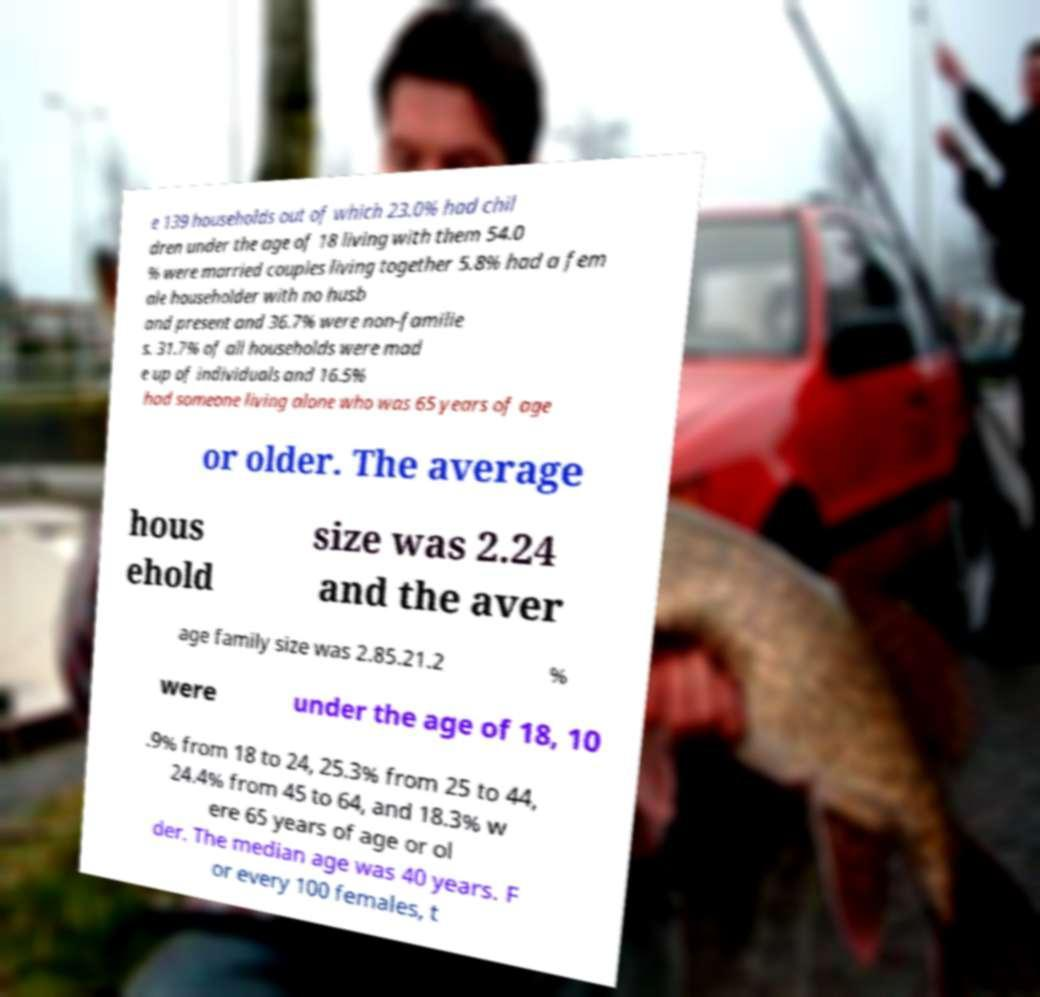What messages or text are displayed in this image? I need them in a readable, typed format. e 139 households out of which 23.0% had chil dren under the age of 18 living with them 54.0 % were married couples living together 5.8% had a fem ale householder with no husb and present and 36.7% were non-familie s. 31.7% of all households were mad e up of individuals and 16.5% had someone living alone who was 65 years of age or older. The average hous ehold size was 2.24 and the aver age family size was 2.85.21.2 % were under the age of 18, 10 .9% from 18 to 24, 25.3% from 25 to 44, 24.4% from 45 to 64, and 18.3% w ere 65 years of age or ol der. The median age was 40 years. F or every 100 females, t 